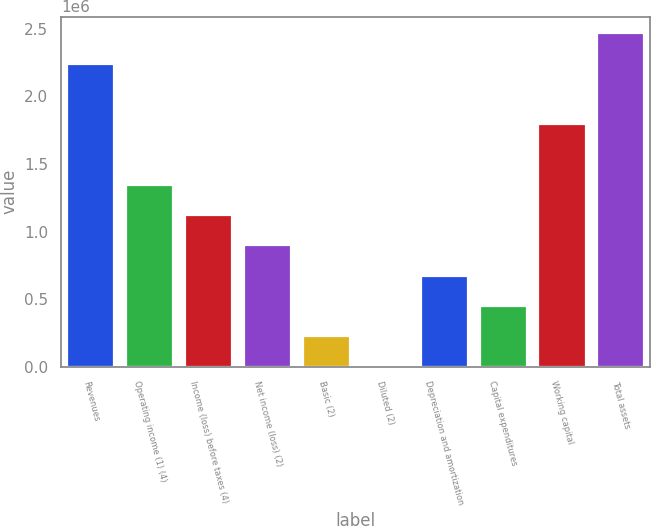<chart> <loc_0><loc_0><loc_500><loc_500><bar_chart><fcel>Revenues<fcel>Operating income (1) (4)<fcel>Income (loss) before taxes (4)<fcel>Net income (loss) (2)<fcel>Basic (2)<fcel>Diluted (2)<fcel>Depreciation and amortization<fcel>Capital expenditures<fcel>Working capital<fcel>Total assets<nl><fcel>2.24274e+06<fcel>1.34564e+06<fcel>1.12137e+06<fcel>897095<fcel>224274<fcel>0.9<fcel>672821<fcel>448548<fcel>1.79419e+06<fcel>2.46701e+06<nl></chart> 